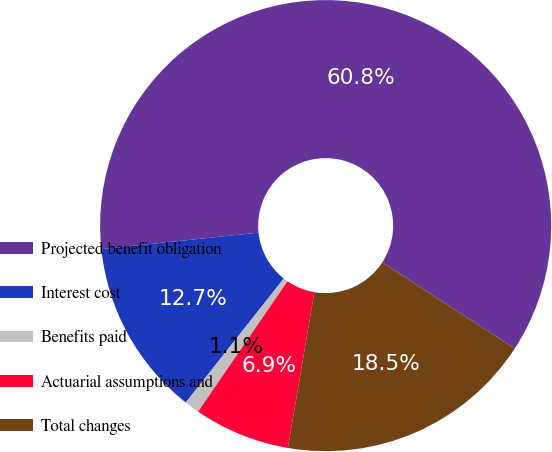Convert chart. <chart><loc_0><loc_0><loc_500><loc_500><pie_chart><fcel>Projected benefit obligation<fcel>Interest cost<fcel>Benefits paid<fcel>Actuarial assumptions and<fcel>Total changes<nl><fcel>60.83%<fcel>12.69%<fcel>1.08%<fcel>6.89%<fcel>18.5%<nl></chart> 